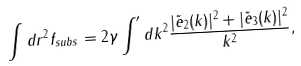<formula> <loc_0><loc_0><loc_500><loc_500>\int d { r } ^ { 2 } f _ { s u b s } = 2 \gamma \int ^ { \prime } d { k } ^ { 2 } \frac { | \tilde { e } _ { 2 } ( { k } ) | ^ { 2 } + | \tilde { e } _ { 3 } ( { k } ) | ^ { 2 } } { k ^ { 2 } } ,</formula> 